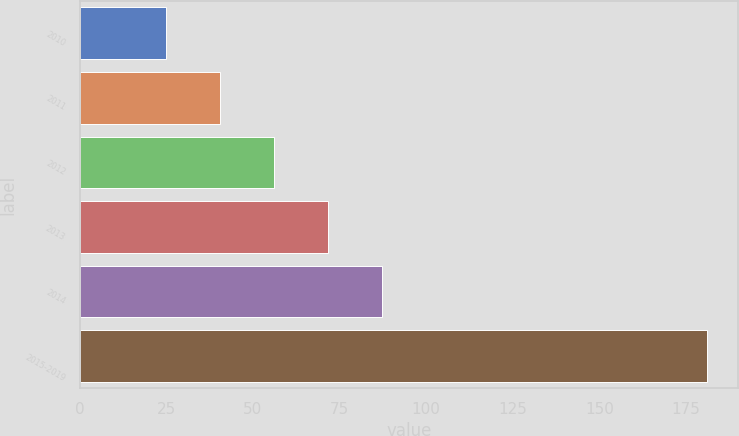Convert chart. <chart><loc_0><loc_0><loc_500><loc_500><bar_chart><fcel>2010<fcel>2011<fcel>2012<fcel>2013<fcel>2014<fcel>2015-2019<nl><fcel>25<fcel>40.6<fcel>56.2<fcel>71.8<fcel>87.4<fcel>181<nl></chart> 